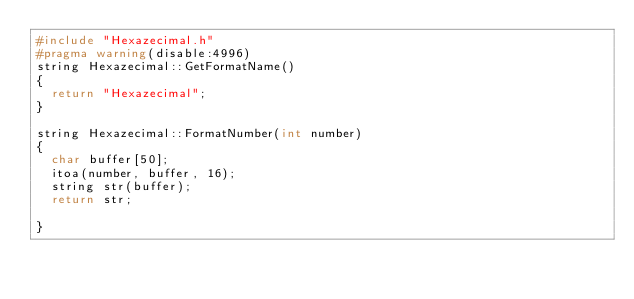<code> <loc_0><loc_0><loc_500><loc_500><_C++_>#include "Hexazecimal.h"
#pragma warning(disable:4996)
string Hexazecimal::GetFormatName()
{
	return "Hexazecimal";
}

string Hexazecimal::FormatNumber(int number)
{
	char buffer[50];
	itoa(number, buffer, 16);
	string str(buffer);
	return str;

}
</code> 